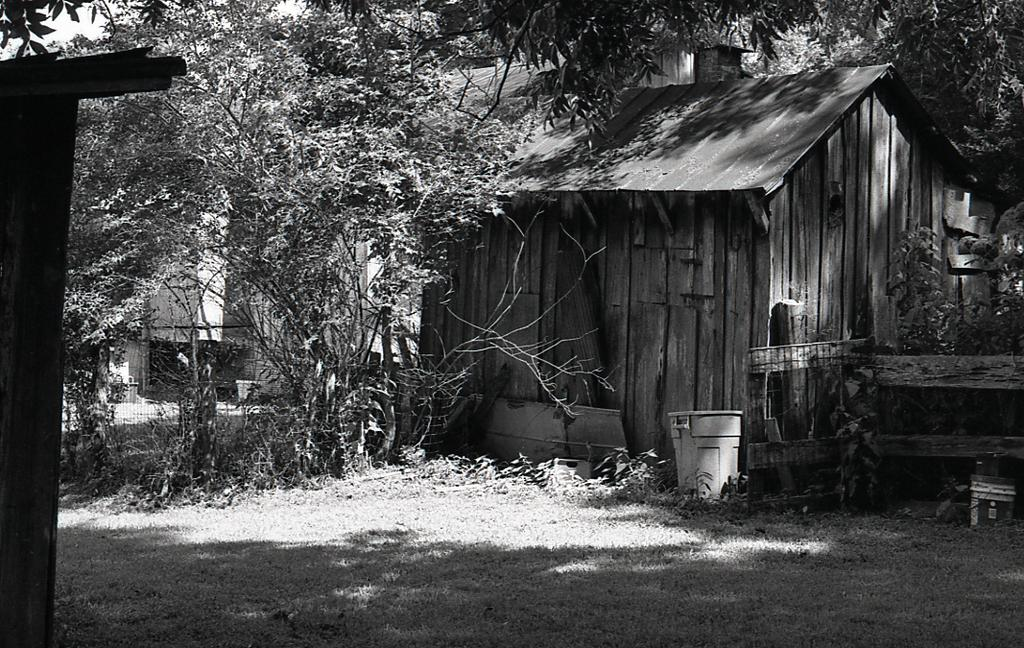What type of house is in the image? There is a wooden house in the image. What can be found near the wooden house? There is a trash bin in the image. What other wooden feature is present in the image? There is a wooden railing in the image. What natural elements can be seen in the image? There are trees visible in the image. What type of chain is hanging from the wooden railing in the image? There is no chain hanging from the wooden railing in the image. 